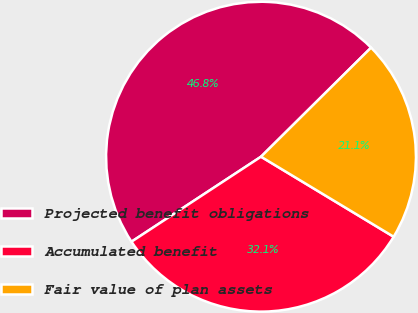<chart> <loc_0><loc_0><loc_500><loc_500><pie_chart><fcel>Projected benefit obligations<fcel>Accumulated benefit<fcel>Fair value of plan assets<nl><fcel>46.82%<fcel>32.12%<fcel>21.07%<nl></chart> 